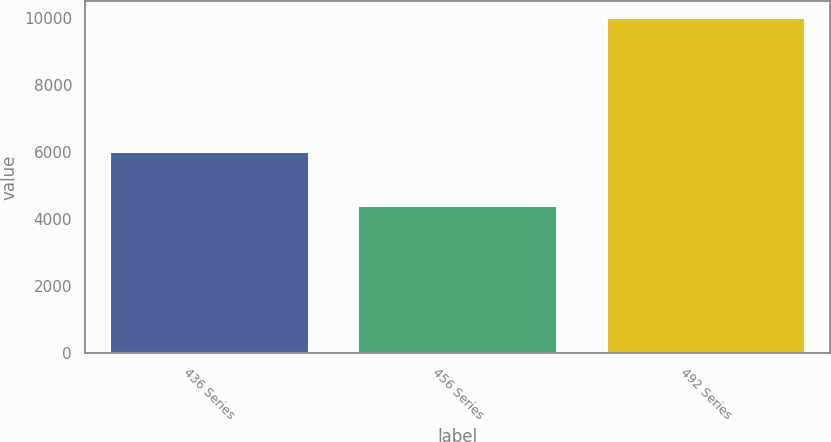<chart> <loc_0><loc_0><loc_500><loc_500><bar_chart><fcel>436 Series<fcel>456 Series<fcel>492 Series<nl><fcel>5992<fcel>4389<fcel>10000<nl></chart> 